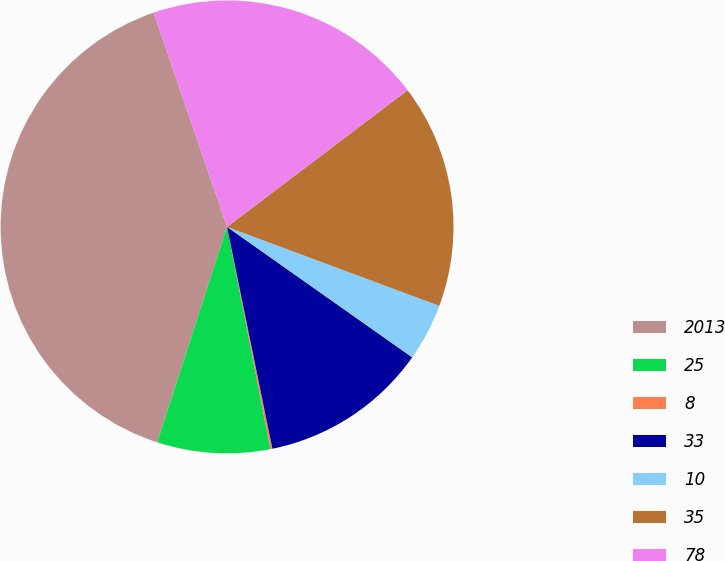Convert chart to OTSL. <chart><loc_0><loc_0><loc_500><loc_500><pie_chart><fcel>2013<fcel>25<fcel>8<fcel>33<fcel>10<fcel>35<fcel>78<nl><fcel>39.75%<fcel>8.06%<fcel>0.14%<fcel>12.02%<fcel>4.1%<fcel>15.98%<fcel>19.94%<nl></chart> 